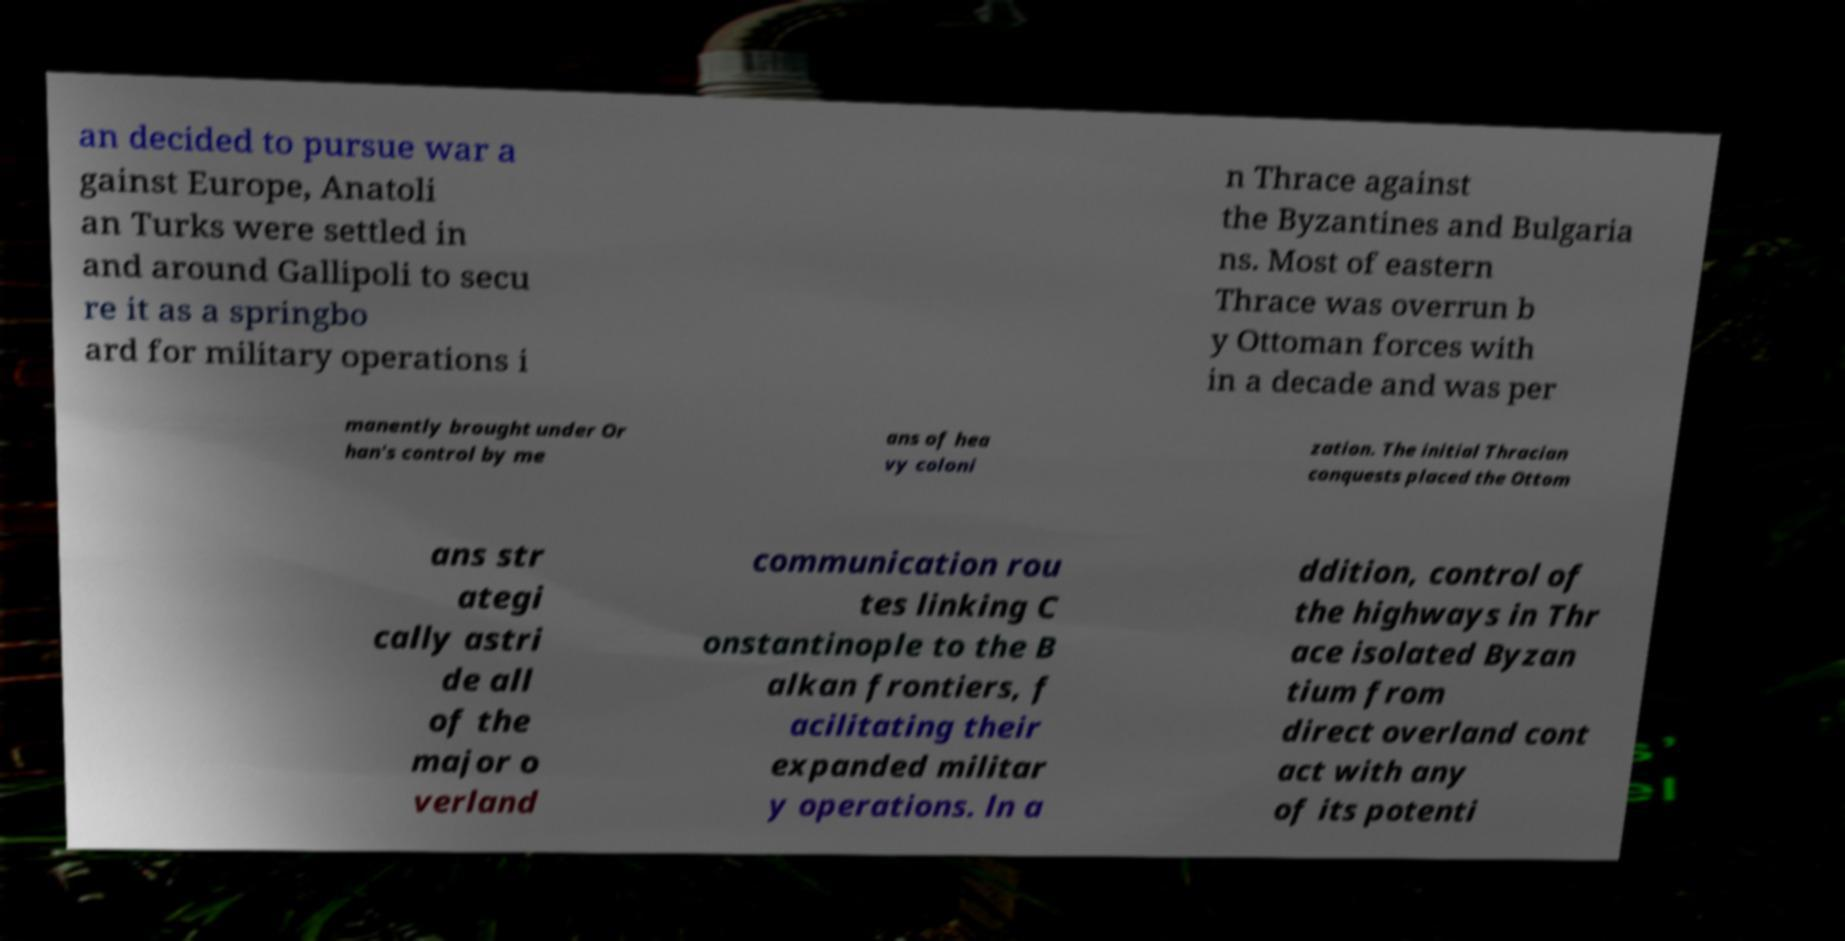Please identify and transcribe the text found in this image. an decided to pursue war a gainst Europe, Anatoli an Turks were settled in and around Gallipoli to secu re it as a springbo ard for military operations i n Thrace against the Byzantines and Bulgaria ns. Most of eastern Thrace was overrun b y Ottoman forces with in a decade and was per manently brought under Or han's control by me ans of hea vy coloni zation. The initial Thracian conquests placed the Ottom ans str ategi cally astri de all of the major o verland communication rou tes linking C onstantinople to the B alkan frontiers, f acilitating their expanded militar y operations. ln a ddition, control of the highways in Thr ace isolated Byzan tium from direct overland cont act with any of its potenti 